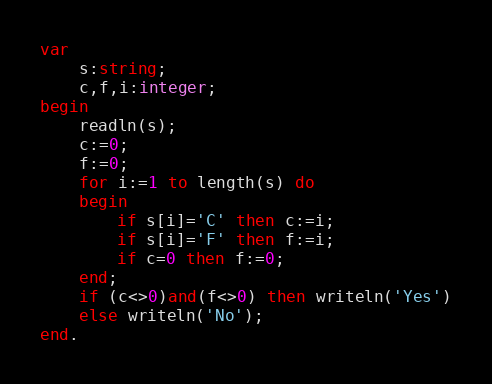Convert code to text. <code><loc_0><loc_0><loc_500><loc_500><_Pascal_>var
    s:string;
	c,f,i:integer;
begin
    readln(s);
	c:=0;
	f:=0;
	for i:=1 to length(s) do
	begin
	    if s[i]='C' then c:=i;
		if s[i]='F' then f:=i;
        if c=0 then f:=0;
	end;
    if (c<>0)and(f<>0) then writeln('Yes')
	else writeln('No');
end.</code> 